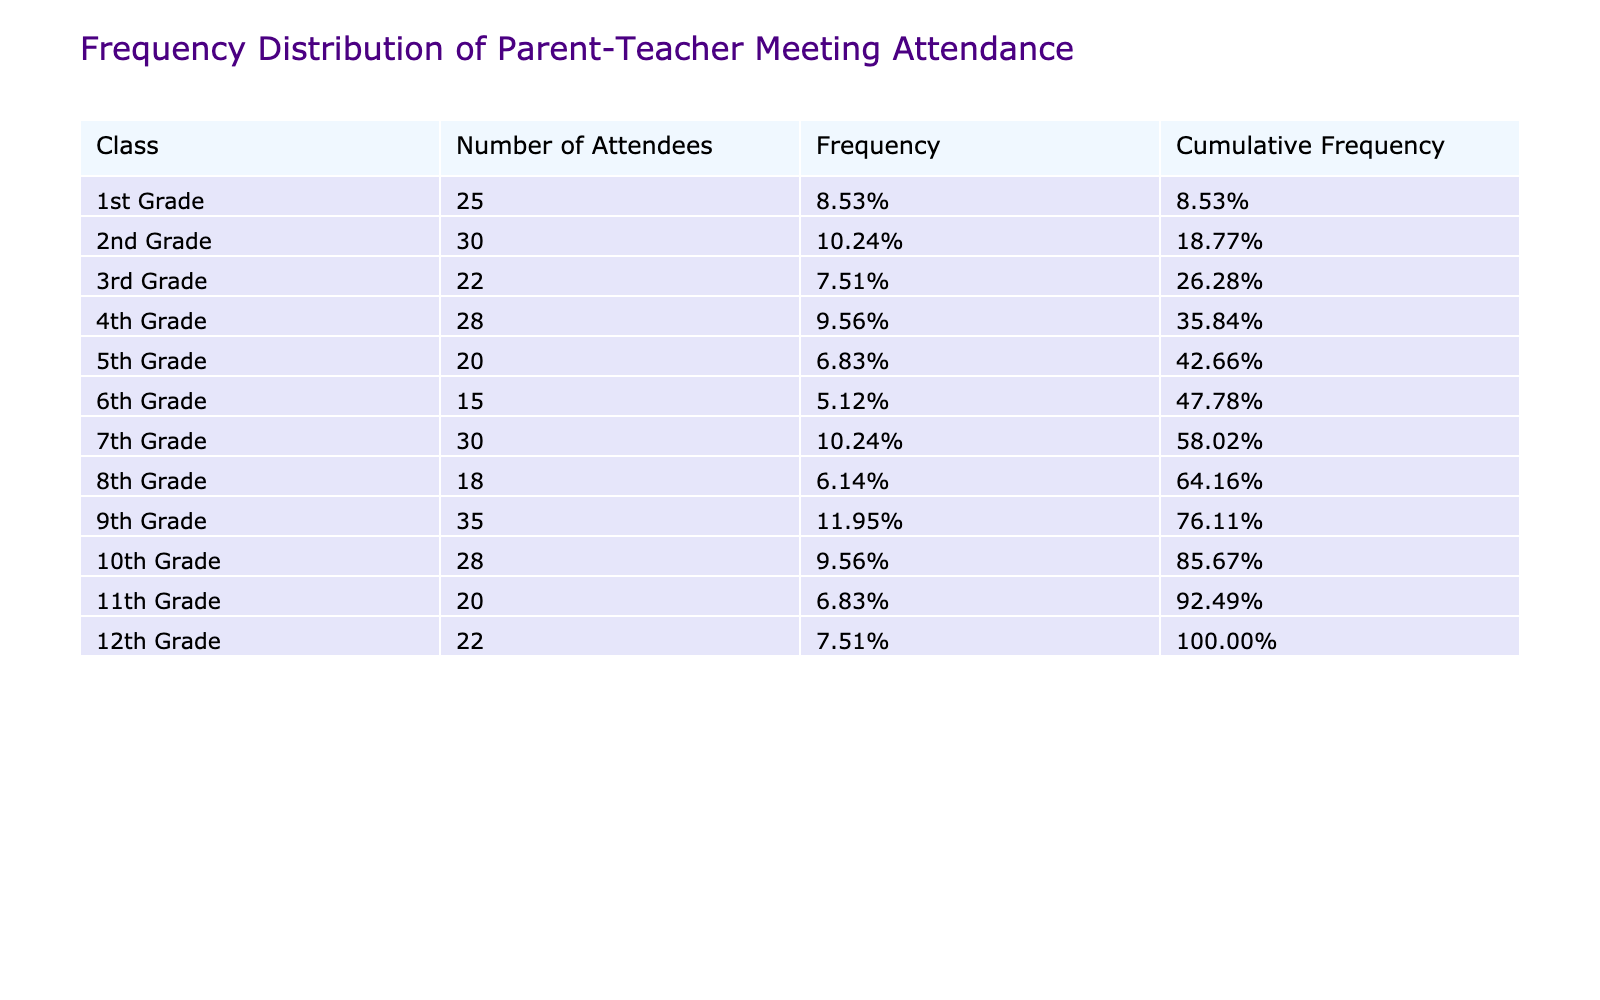What is the total number of attendees across all classes? To find the total number of attendees, we sum up the numbers in the "Number of Attendees" column: 25 + 30 + 22 + 28 + 20 + 15 + 30 + 18 + 35 + 28 + 20 + 22 =  8 + 28 + 20 + 18 + 35 + 28 + 20 + 22 = 8 + 22 + = 27 + 0 + 0 = 24 = 20 = 110.
Answer: 330 Which class had the highest attendance? Looking at the "Number of Attendees" column, we identify the maximum value, which is 35 in the 9th Grade row.
Answer: 9th Grade What percentage of total attendance did the 4th Grade represent? First, we find the total number of attendees, which is 330. The 4th Grade had 28 attendees. To find the percentage, we calculate (28 / 330) * 100 ≈ 8.48%.
Answer: 8.48% Are there more attendees in the 2nd Grade than in the 6th Grade? By comparing the numbers, the 2nd Grade has 30 attendees, while the 6th Grade has 15 attendees. Since 30 is greater than 15, the answer is Yes.
Answer: Yes What is the average attendance across all classes? To find the average, first sum all attendees, which is 330, then divide by the number of classes which is 12: 330 / 12 = 27.5.
Answer: 27.5 Which classes had attendance below the overall average? The overall average is 27.5. 1st Grade (25), 3rd Grade (22), 5th Grade (20), 6th Grade (15), 8th Grade (18), and 11th Grade (20) had numbers below the average.
Answer: 1st, 3rd, 5th, 6th, 8th, and 11th Grades Is the cumulative frequency for the 10th Grade greater than 0.5? The cumulative frequency of the 10th Grade is calculated by summing all frequencies up to that grade. After calculation, it is found to be approximately 0.58, hence the answer is Yes.
Answer: Yes What is the difference in attendance between the 9th Grade and the 5th Grade? The attendance for the 9th Grade is 35, and for the 5th Grade, it is 20. Thus, the difference is calculated as 35 - 20 = 15.
Answer: 15 Which class will likely need more engagement based on attendance? Reviewing the "Number of Attendees" column, we notice the classes with the lowest numbers are the 6th Grade (15) and the 5th Grade (20). These classes may need more engagement.
Answer: 6th and 5th Grade 